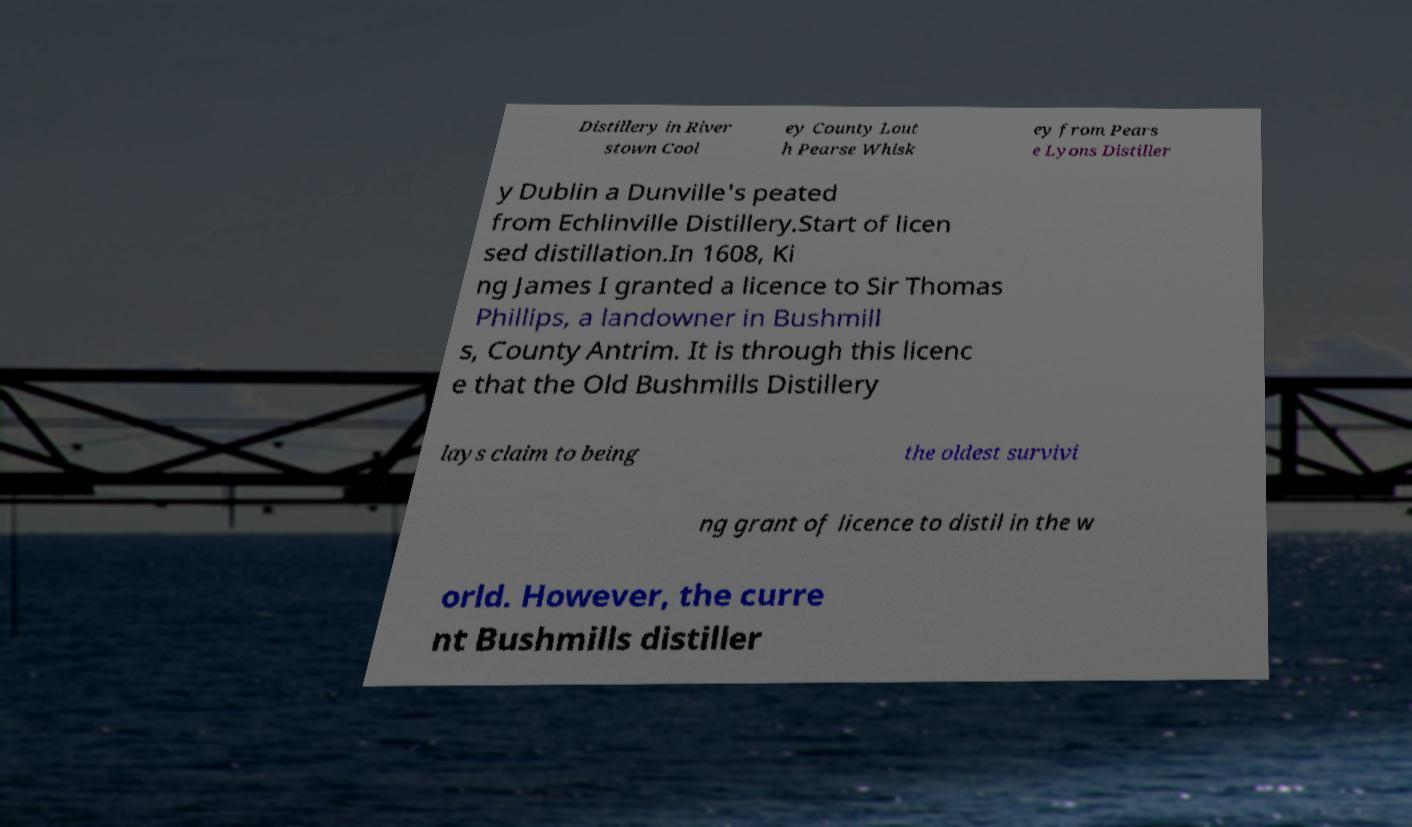What messages or text are displayed in this image? I need them in a readable, typed format. Distillery in River stown Cool ey County Lout h Pearse Whisk ey from Pears e Lyons Distiller y Dublin a Dunville's peated from Echlinville Distillery.Start of licen sed distillation.In 1608, Ki ng James I granted a licence to Sir Thomas Phillips, a landowner in Bushmill s, County Antrim. It is through this licenc e that the Old Bushmills Distillery lays claim to being the oldest survivi ng grant of licence to distil in the w orld. However, the curre nt Bushmills distiller 